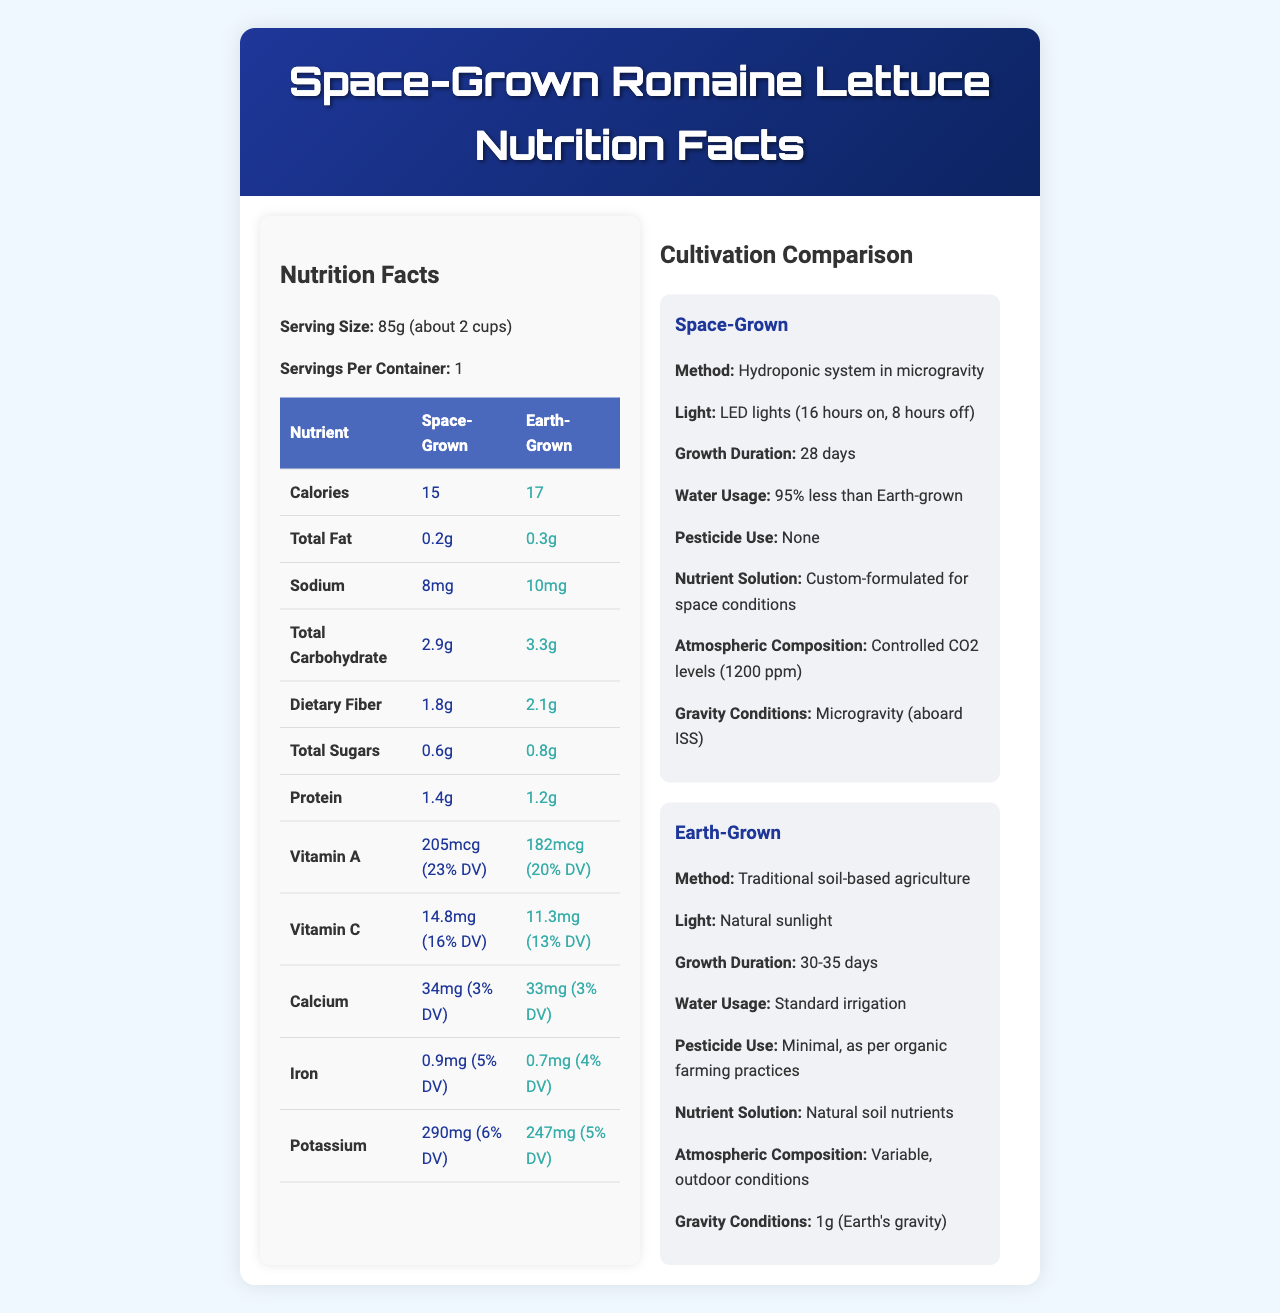what is the serving size for Space-Grown Romaine Lettuce? The document states that the serving size for Space-Grown Romaine Lettuce is 85g, which is about 2 cups.
Answer: 85g (about 2 cups) how many calories are in a serving of Earth-Grown Romaine Lettuce? The Nutrition Facts table shows that a serving of Earth-Grown Romaine Lettuce contains 17 calories.
Answer: 17 what is the percentage daily value (% DV) of Vitamin A in Space-Grown Romaine Lettuce? The document lists that Space-Grown Romaine Lettuce contains 205mcg of Vitamin A, which is 23% of the daily value.
Answer: 23% DV which type of lettuce has a higher protein content? According to the document, Space-Grown Romaine Lettuce has 1.4g of protein per serving, while Earth-Grown has 1.2g.
Answer: Space-Grown how much sodium is in a serving of Space-Grown Romaine Lettuce? The document specifies that there is 8mg of sodium in a serving of Space-Grown Romaine Lettuce.
Answer: 8mg is the amount of dietary fiber in Space-Grown Lettuce higher than in Earth-Grown Lettuce? The document shows that Space-Grown Lettuce has 1.8g of dietary fiber, while Earth-Grown Lettuce has 2.1g.
Answer: No what is the atmospheric composition for Space-Grown Romaine Lettuce? The document states that Space-Grown Romaine Lettuce is grown in an environment with controlled CO2 levels of 1200 ppm.
Answer: Controlled CO2 levels (1200 ppm) what are the major differences in vitamin content between space-grown and Earth-grown lettuce? The document indicates that Space-grown lettuce contains 205mcg of Vitamin A versus 182mcg in Earth-grown, and 14.8mg of Vitamin C versus 11.3mg in Earth-grown.
Answer: Space-grown lettuce has higher amounts of Vitamin A and Vitamin C compared to Earth-grown lettuce. which lettuce has a higher antioxidant content? The document notes that Space-Grown Lettuce contains 15% higher antioxidants compared to Earth-Grown Lettuce.
Answer: Space-Grown describe the main differences between the cultivation methods used for Space-Grown and Earth-Grown Lettuce The document outlines that Space-Grown Lettuce employs a hydroponic system, LED lights, controlled atmospheric conditions, and no pesticides, while Earth-Grown Lettuce uses soil-based methods, sunlight, standard irrigation, and minimal pesticide use.
Answer: Space-Grown Lettuce is cultivated using a hydroponic system in microgravity with LED lights and controlled CO2 levels, while Earth-Grown Lettuce uses traditional soil-based agriculture with natural sunlight and standard irrigation. how long does it take for Space-Grown Romaine Lettuce to reach maturity? According to the document, Space-Grown Romaine Lettuce takes 28 days to grow.
Answer: 28 days which nutrient solution is used for Space-Grown Lettuce? The document indicates that Space-Grown Lettuce is fed with a nutrient solution that is custom-formulated for space conditions.
Answer: Custom-formulated for space conditions how much total carbohydrate is in a serving of Earth-Grown Romaine Lettuce? The document lists that Earth-Grown Romaine Lettuce contains 3.3g of total carbohydrate per serving.
Answer: 3.3g what type of lighting is used for growing Space-Grown Romaine Lettuce? The document specifies that LED lights are used with a cycle of 16 hours on and 8 hours off.
Answer: LED lights (16 hours on, 8 hours off) does the document provide information on genetic modification of the lettuce? The document explicitly mentions that neither Space-Grown nor Earth-Grown Lettuce are genetically modified.
Answer: Yes 